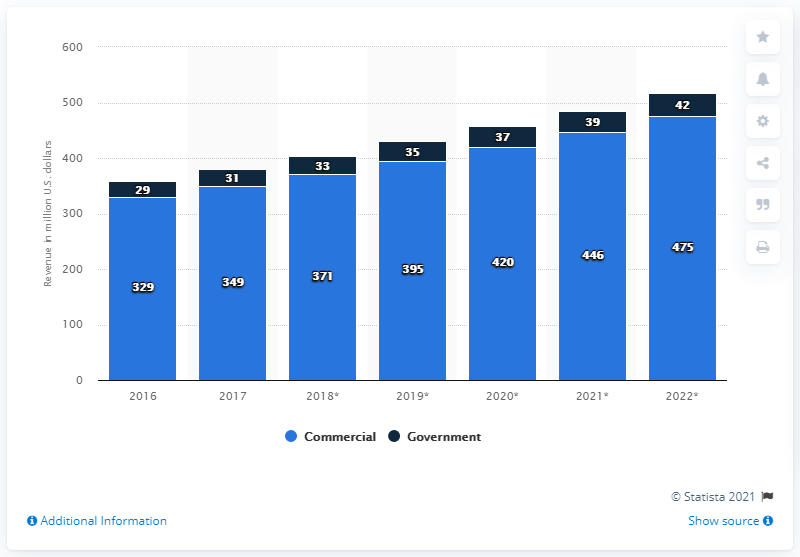Give some essential details in this illustration. In 2017, the commercial cyber security segment generated approximately 349 million US dollars. 